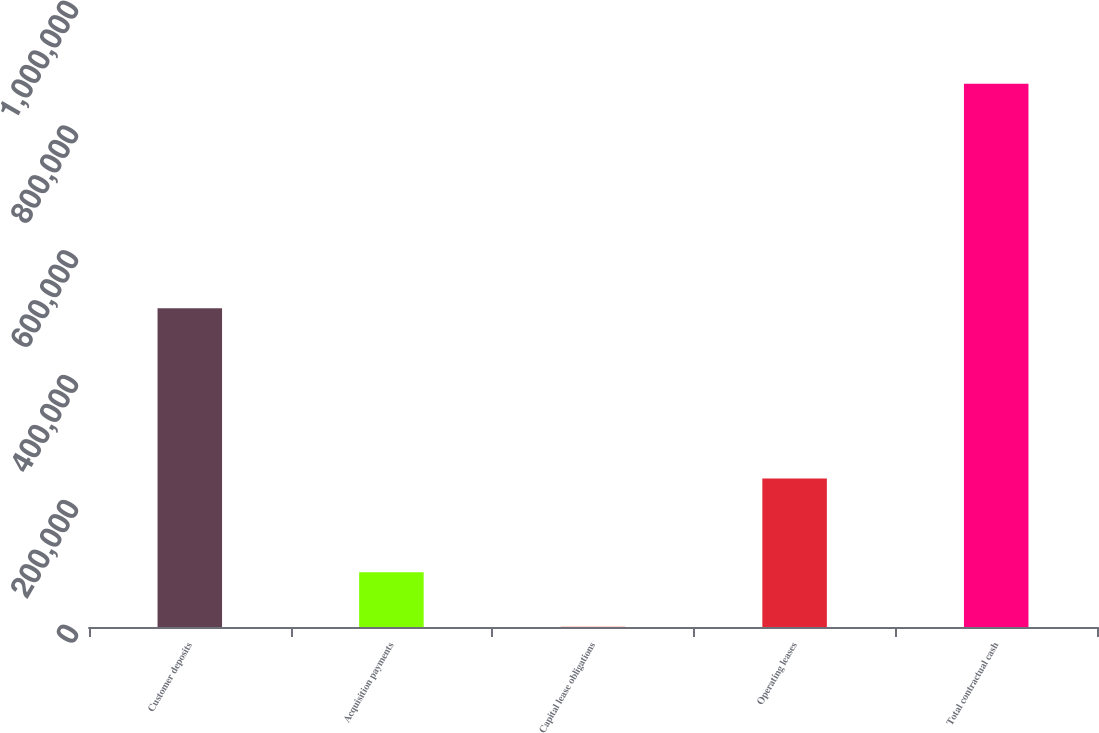Convert chart. <chart><loc_0><loc_0><loc_500><loc_500><bar_chart><fcel>Customer deposits<fcel>Acquisition payments<fcel>Capital lease obligations<fcel>Operating leases<fcel>Total contractual cash<nl><fcel>511010<fcel>87569.4<fcel>557<fcel>238167<fcel>870681<nl></chart> 